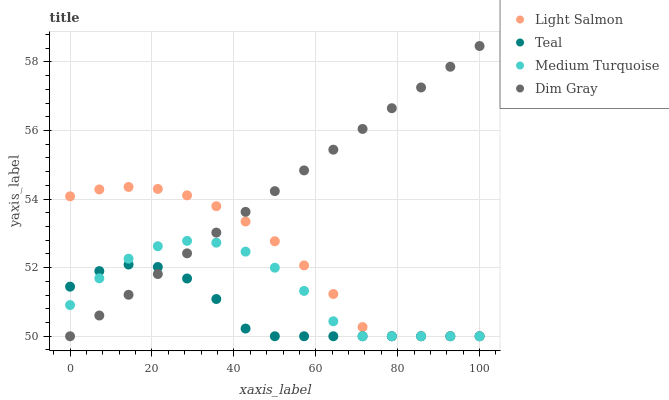Does Teal have the minimum area under the curve?
Answer yes or no. Yes. Does Dim Gray have the maximum area under the curve?
Answer yes or no. Yes. Does Medium Turquoise have the minimum area under the curve?
Answer yes or no. No. Does Medium Turquoise have the maximum area under the curve?
Answer yes or no. No. Is Dim Gray the smoothest?
Answer yes or no. Yes. Is Medium Turquoise the roughest?
Answer yes or no. Yes. Is Medium Turquoise the smoothest?
Answer yes or no. No. Is Dim Gray the roughest?
Answer yes or no. No. Does Light Salmon have the lowest value?
Answer yes or no. Yes. Does Dim Gray have the highest value?
Answer yes or no. Yes. Does Medium Turquoise have the highest value?
Answer yes or no. No. Does Light Salmon intersect Teal?
Answer yes or no. Yes. Is Light Salmon less than Teal?
Answer yes or no. No. Is Light Salmon greater than Teal?
Answer yes or no. No. 